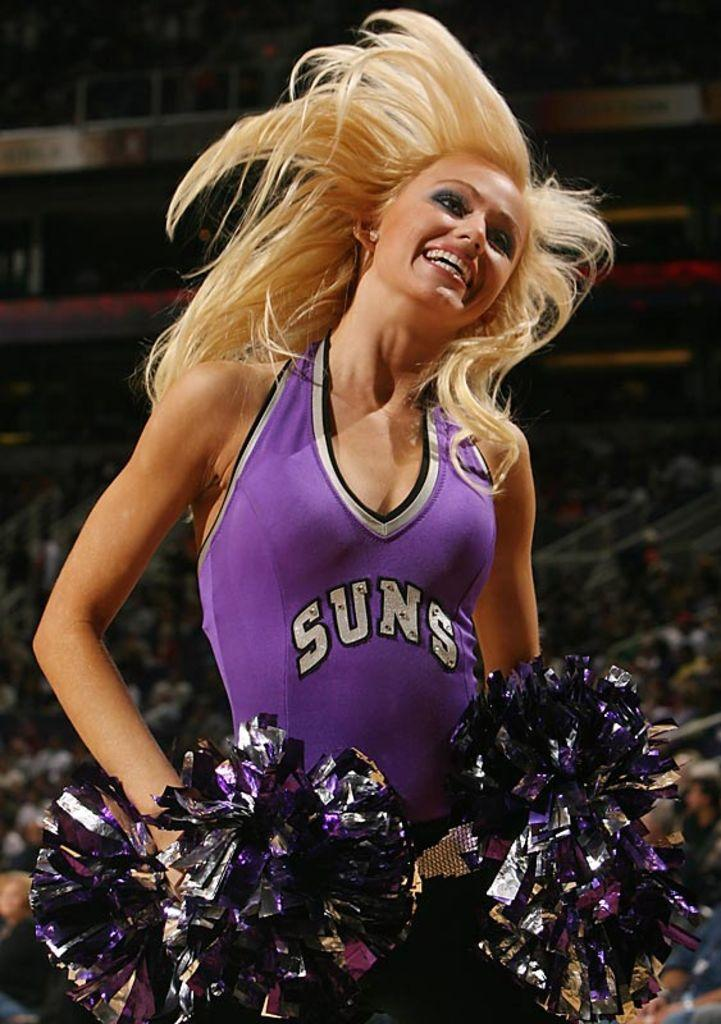Provide a one-sentence caption for the provided image. Suns basketball cheerleader smiling for a picture and wearing her pom poms. 